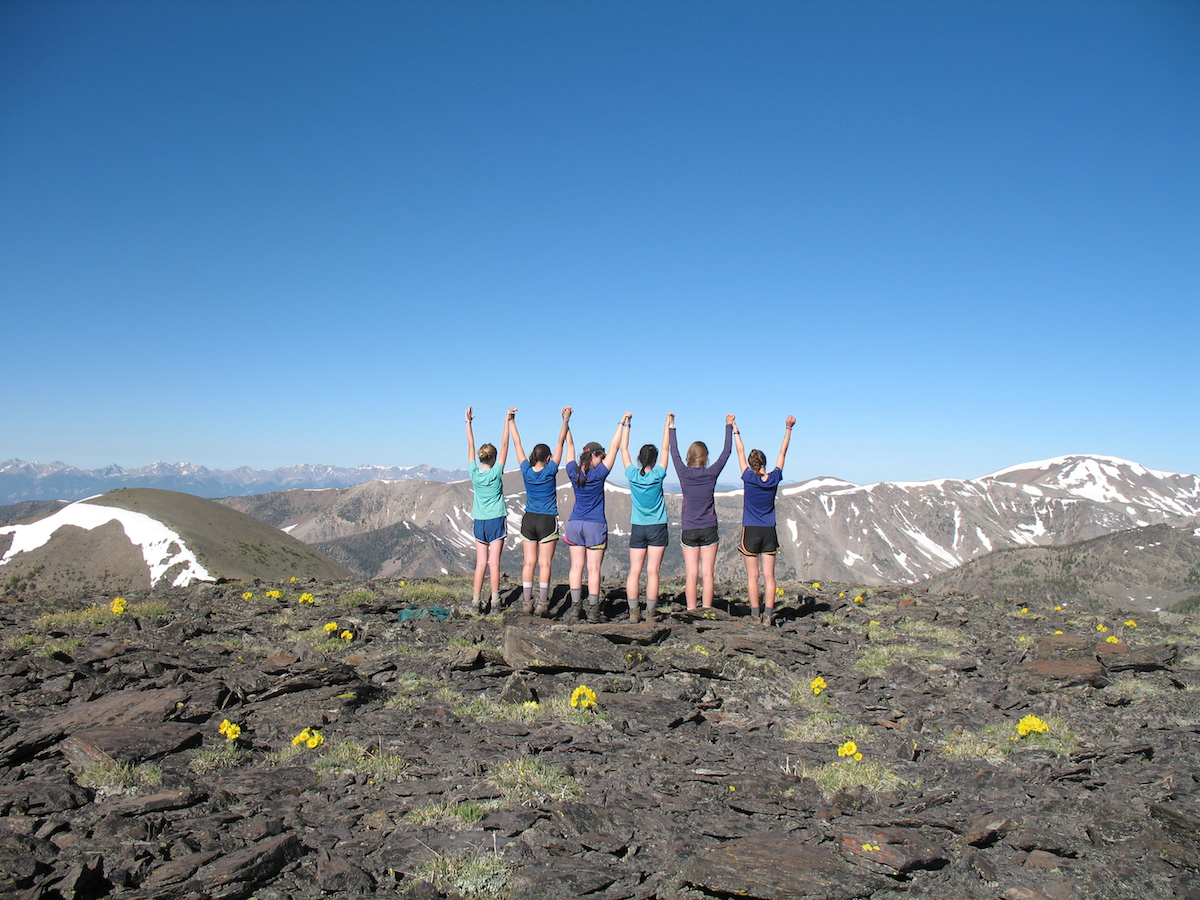Based on the direction of the shadows and the snow conditions on the mountain peaks, what could be the approximate time of day and season when this photograph was taken? The positioning of the shadows, which stretch to the right and slightly behind the individuals, suggests that the sun is towards the west, indicating it is afternoon. Observing the snow on the distant peaks coupled with the lack of snow around the individuals and their summer attire (short sleeves and shorts), we can deduce it's summer. The angle and intensity of the sunlight, combined with these observations, make it most likely that this photograph was captured in the late afternoon, as the sun begins to dip but still provides ample daylight. 